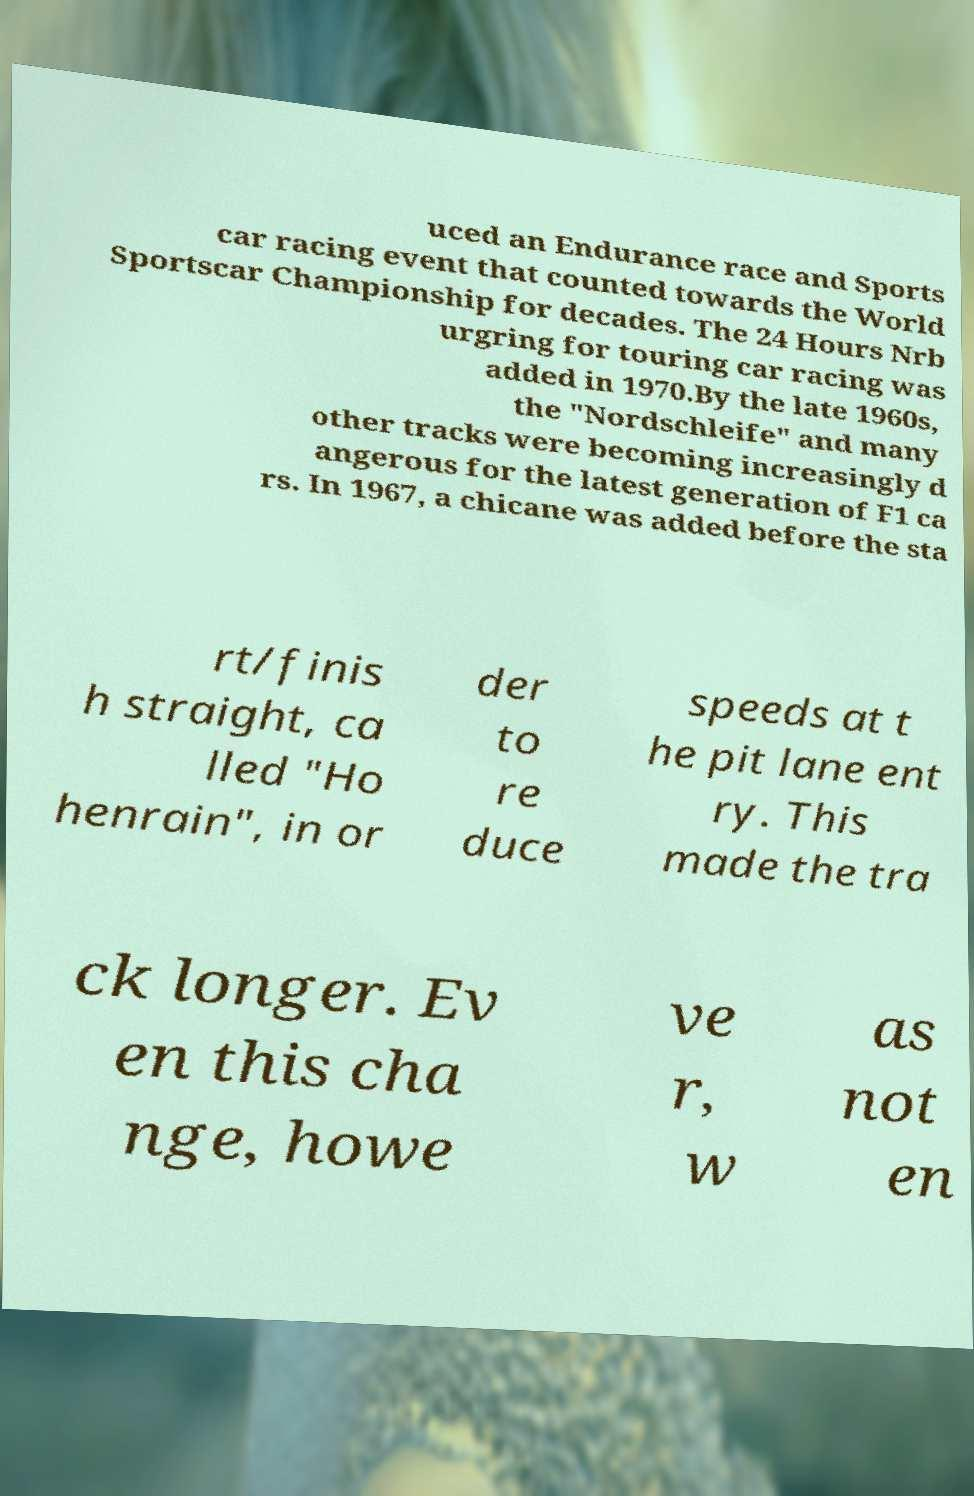There's text embedded in this image that I need extracted. Can you transcribe it verbatim? uced an Endurance race and Sports car racing event that counted towards the World Sportscar Championship for decades. The 24 Hours Nrb urgring for touring car racing was added in 1970.By the late 1960s, the "Nordschleife" and many other tracks were becoming increasingly d angerous for the latest generation of F1 ca rs. In 1967, a chicane was added before the sta rt/finis h straight, ca lled "Ho henrain", in or der to re duce speeds at t he pit lane ent ry. This made the tra ck longer. Ev en this cha nge, howe ve r, w as not en 